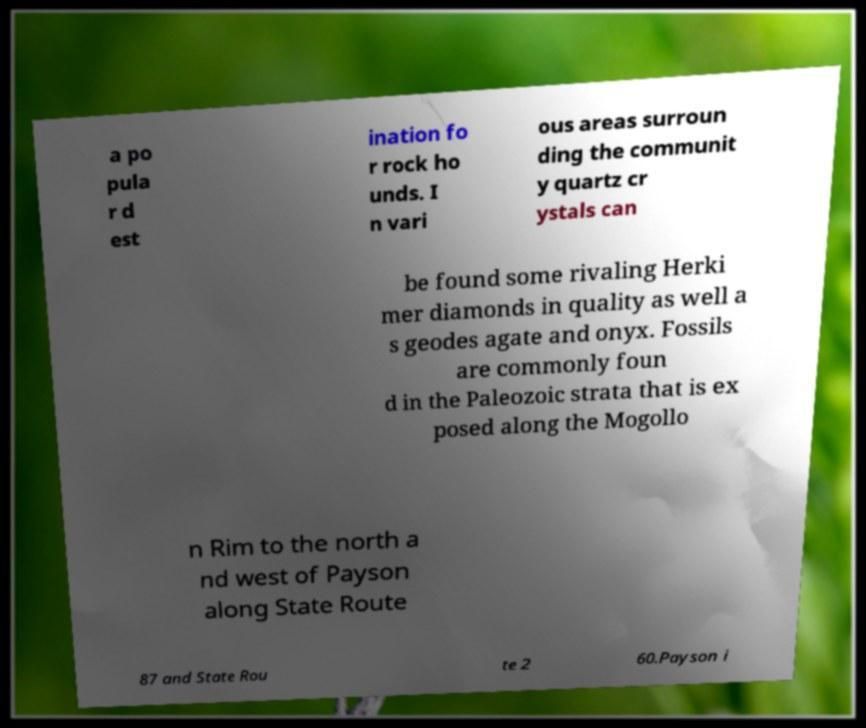Can you read and provide the text displayed in the image?This photo seems to have some interesting text. Can you extract and type it out for me? a po pula r d est ination fo r rock ho unds. I n vari ous areas surroun ding the communit y quartz cr ystals can be found some rivaling Herki mer diamonds in quality as well a s geodes agate and onyx. Fossils are commonly foun d in the Paleozoic strata that is ex posed along the Mogollo n Rim to the north a nd west of Payson along State Route 87 and State Rou te 2 60.Payson i 